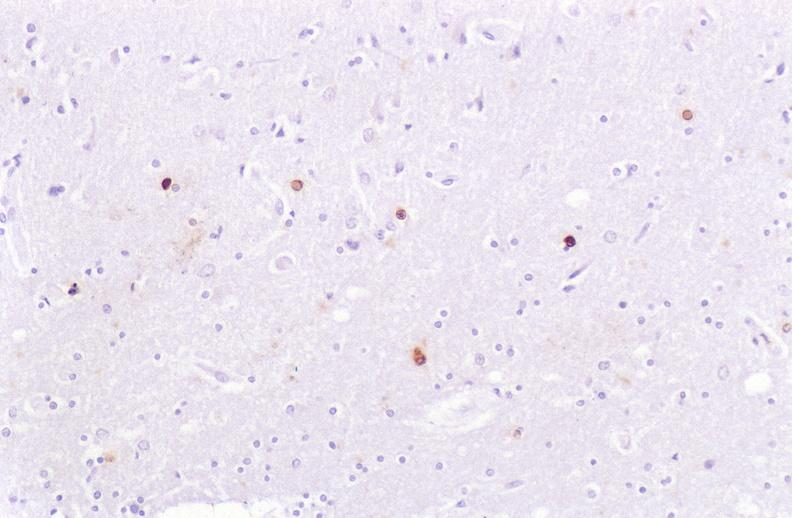where is this?
Answer the question using a single word or phrase. Nervous 